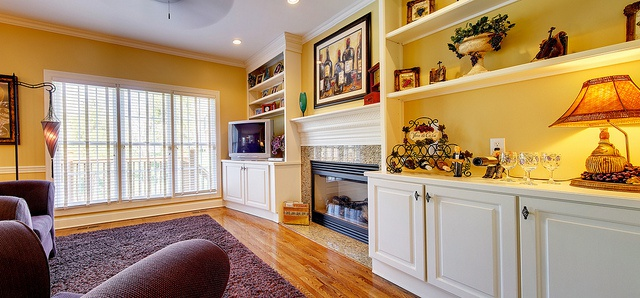Describe the objects in this image and their specific colors. I can see couch in darkgray, black, maroon, and gray tones, potted plant in darkgray, black, olive, and tan tones, chair in darkgray, black, and purple tones, tv in darkgray, black, navy, and gray tones, and vase in darkgray, olive, tan, black, and orange tones in this image. 